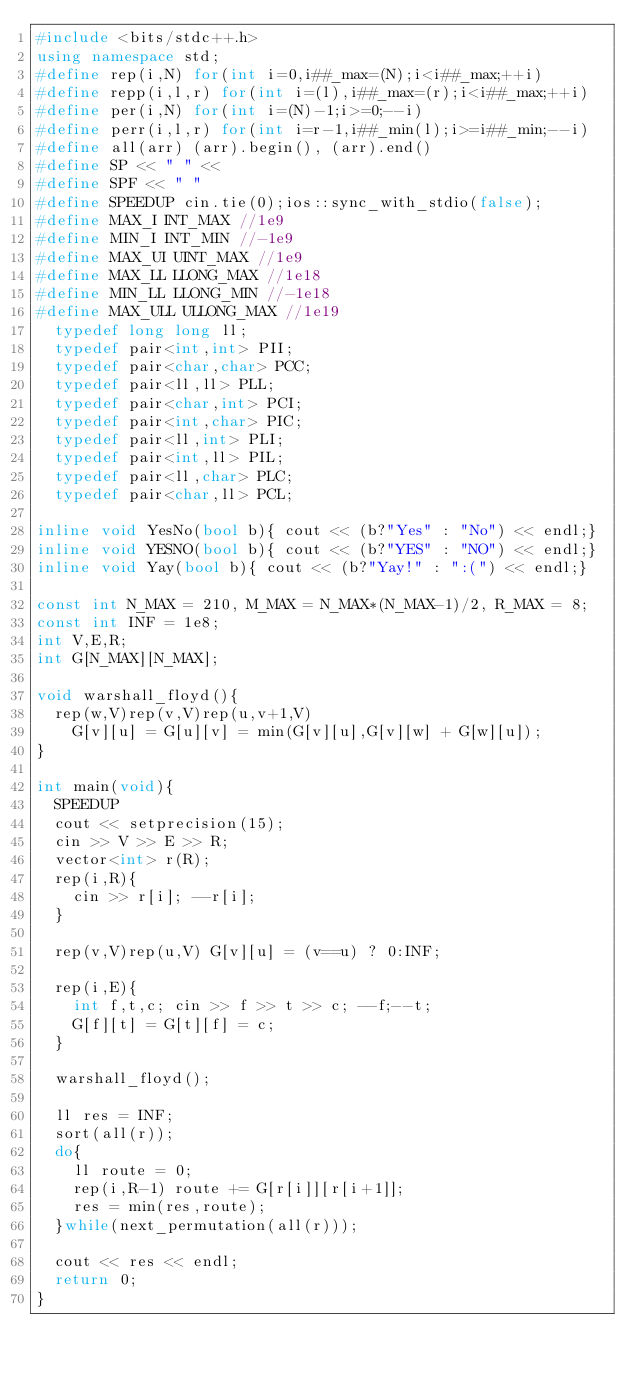<code> <loc_0><loc_0><loc_500><loc_500><_C++_>#include <bits/stdc++.h>
using namespace std;
#define rep(i,N) for(int i=0,i##_max=(N);i<i##_max;++i)
#define repp(i,l,r) for(int i=(l),i##_max=(r);i<i##_max;++i)
#define per(i,N) for(int i=(N)-1;i>=0;--i)
#define perr(i,l,r) for(int i=r-1,i##_min(l);i>=i##_min;--i)
#define all(arr) (arr).begin(), (arr).end()
#define SP << " " <<
#define SPF << " "
#define SPEEDUP cin.tie(0);ios::sync_with_stdio(false);
#define MAX_I INT_MAX //1e9
#define MIN_I INT_MIN //-1e9
#define MAX_UI UINT_MAX //1e9
#define MAX_LL LLONG_MAX //1e18
#define MIN_LL LLONG_MIN //-1e18
#define MAX_ULL ULLONG_MAX //1e19
  typedef long long ll;
  typedef pair<int,int> PII;
  typedef pair<char,char> PCC;
  typedef pair<ll,ll> PLL;
  typedef pair<char,int> PCI;
  typedef pair<int,char> PIC;
  typedef pair<ll,int> PLI;
  typedef pair<int,ll> PIL; 
  typedef pair<ll,char> PLC; 
  typedef pair<char,ll> PCL; 

inline void YesNo(bool b){ cout << (b?"Yes" : "No") << endl;}
inline void YESNO(bool b){ cout << (b?"YES" : "NO") << endl;}
inline void Yay(bool b){ cout << (b?"Yay!" : ":(") << endl;}

const int N_MAX = 210, M_MAX = N_MAX*(N_MAX-1)/2, R_MAX = 8;
const int INF = 1e8;
int V,E,R;
int G[N_MAX][N_MAX];

void warshall_floyd(){
  rep(w,V)rep(v,V)rep(u,v+1,V) 
    G[v][u] = G[u][v] = min(G[v][u],G[v][w] + G[w][u]);
}

int main(void){
  SPEEDUP
  cout << setprecision(15);
  cin >> V >> E >> R;
  vector<int> r(R);
  rep(i,R){
    cin >> r[i]; --r[i];
  }

  rep(v,V)rep(u,V) G[v][u] = (v==u) ? 0:INF;

  rep(i,E){
    int f,t,c; cin >> f >> t >> c; --f;--t;
    G[f][t] = G[t][f] = c; 
  }

  warshall_floyd();

  ll res = INF;
  sort(all(r));
  do{
    ll route = 0;
    rep(i,R-1) route += G[r[i]][r[i+1]];
    res = min(res,route);
  }while(next_permutation(all(r)));

  cout << res << endl;
  return 0;
}
</code> 